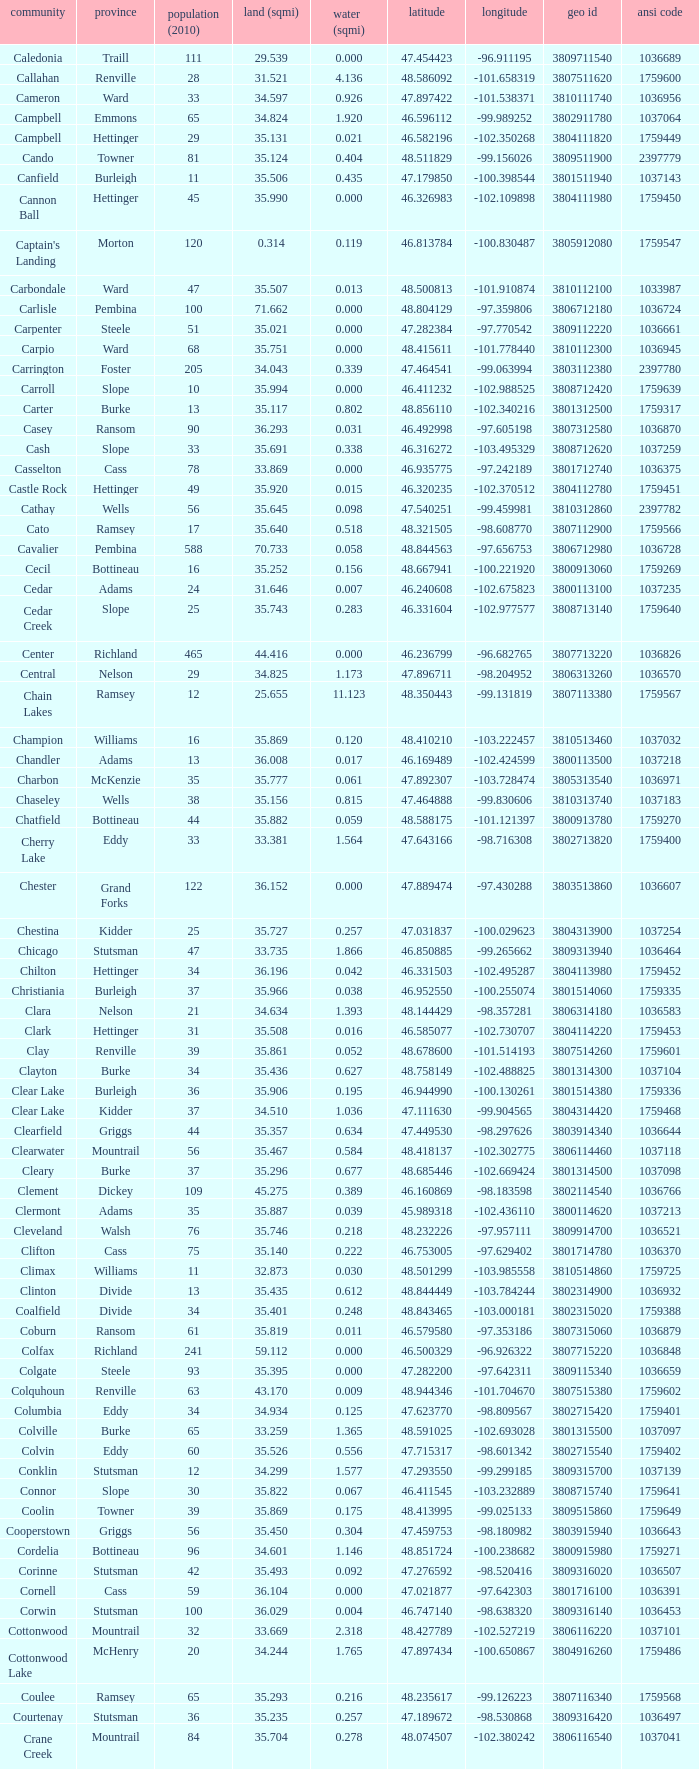Which county had a latitude of 46.770977? Kidder. 